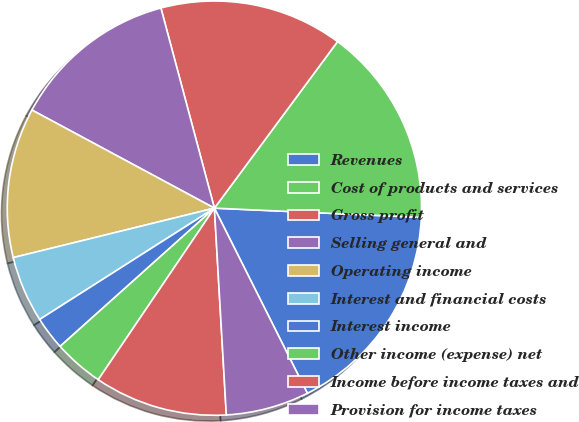Convert chart to OTSL. <chart><loc_0><loc_0><loc_500><loc_500><pie_chart><fcel>Revenues<fcel>Cost of products and services<fcel>Gross profit<fcel>Selling general and<fcel>Operating income<fcel>Interest and financial costs<fcel>Interest income<fcel>Other income (expense) net<fcel>Income before income taxes and<fcel>Provision for income taxes<nl><fcel>16.88%<fcel>15.58%<fcel>14.29%<fcel>12.99%<fcel>11.69%<fcel>5.19%<fcel>2.6%<fcel>3.9%<fcel>10.39%<fcel>6.49%<nl></chart> 